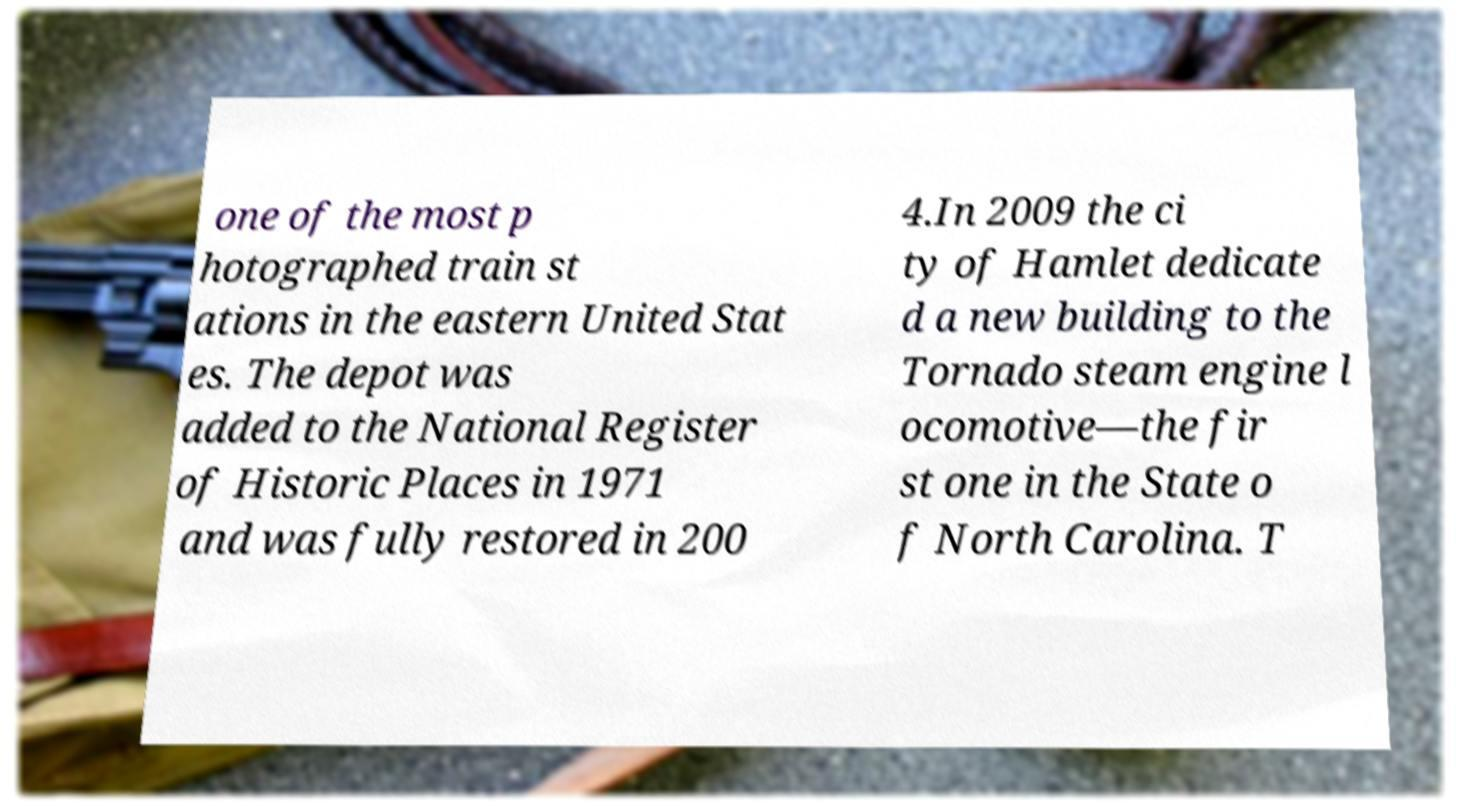Can you accurately transcribe the text from the provided image for me? one of the most p hotographed train st ations in the eastern United Stat es. The depot was added to the National Register of Historic Places in 1971 and was fully restored in 200 4.In 2009 the ci ty of Hamlet dedicate d a new building to the Tornado steam engine l ocomotive—the fir st one in the State o f North Carolina. T 